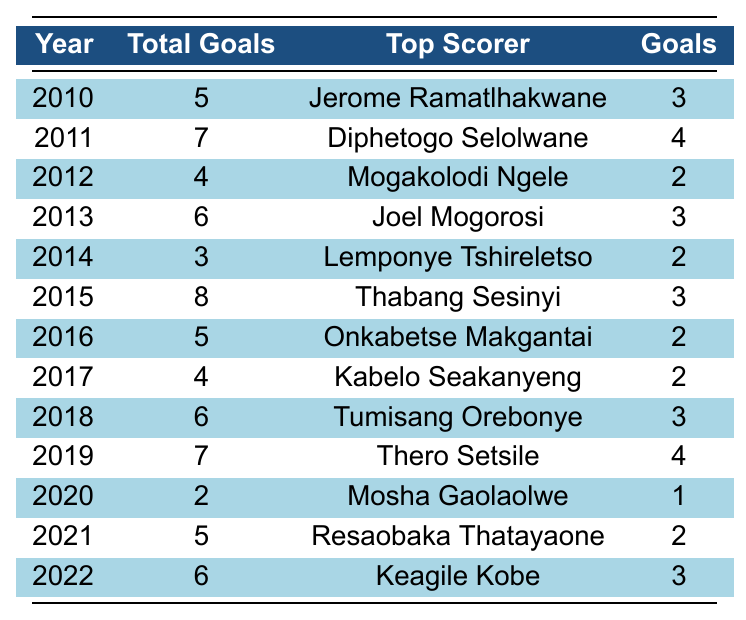What year did Botswana score the most goals? By examining the 'Total Goals' column, the highest number is 8, which occurred in 2015.
Answer: 2015 Who was the top scorer for Botswana in 2019? The table shows that the top scorer in 2019 was Thero Setsile, who scored 4 goals.
Answer: Thero Setsile What is the total number of goals scored by Botswana from 2010 to 2022? Adding up all the total goals from 2010 (5) to 2022 (6), the sum is 5 + 7 + 4 + 6 + 3 + 8 + 5 + 4 + 6 + 7 + 2 + 5 + 6 = 57.
Answer: 57 In which year did Botswana score the least goals? The table indicates that the least goals were scored in 2020 when Botswana scored 2 goals.
Answer: 2020 What is the average number of goals scored by Botswana per year from 2010 to 2022? The total number of goals is 57, and there are 13 years (2010 to 2022). The average is 57/13, which equals approximately 4.38.
Answer: 4.38 Did Botswana score more than 5 goals in 2016? In 2016, the table shows that Botswana scored 5 goals, which is not more than 5. Therefore, the answer is no.
Answer: No Who scored the most goals in 2011, and how many did he score? The table states that Diphetogo Selolwane was the top scorer in 2011, scoring 4 goals.
Answer: Diphetogo Selolwane, 4 goals How many years did Botswana score more than 6 goals? By counting the rows in the 'Total Goals' column, Botswana scored more than 6 goals in 2011 (7), 2015 (8), 2019 (7), which is 3 years total.
Answer: 3 years What was the trend in the total goals scored by Botswana from 2010 to 2022? Analyzing the 'Total Goals' column year by year shows fluctuations, with a peak in 2015 (8 goals) and a low in 2020 (2 goals), indicating no consistent upward or downward trend.
Answer: Fluctuating, no consistent trend Which year had the highest goals scored but did not have the highest top scorer's goals? In 2015, Botswana scored 8 goals; however, the top scorer, Thabang Sesinyi, only scored 3 goals, which is not the highest amongst scoring years.
Answer: 2015 